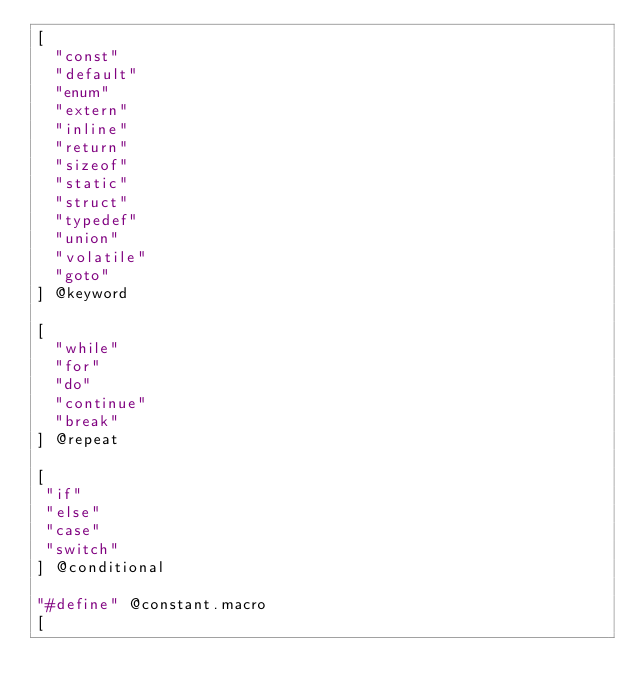<code> <loc_0><loc_0><loc_500><loc_500><_Scheme_>[
  "const"
  "default"
  "enum"
  "extern"
  "inline"
  "return"
  "sizeof"
  "static"
  "struct"
  "typedef"
  "union"
  "volatile"
  "goto"
] @keyword

[
  "while"
  "for"
  "do"
  "continue"
  "break"
] @repeat

[
 "if"
 "else"
 "case"
 "switch"
] @conditional

"#define" @constant.macro
[</code> 